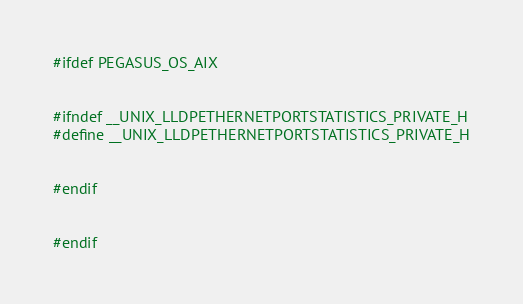Convert code to text. <code><loc_0><loc_0><loc_500><loc_500><_C++_>#ifdef PEGASUS_OS_AIX


#ifndef __UNIX_LLDPETHERNETPORTSTATISTICS_PRIVATE_H
#define __UNIX_LLDPETHERNETPORTSTATISTICS_PRIVATE_H


#endif


#endif
</code> 